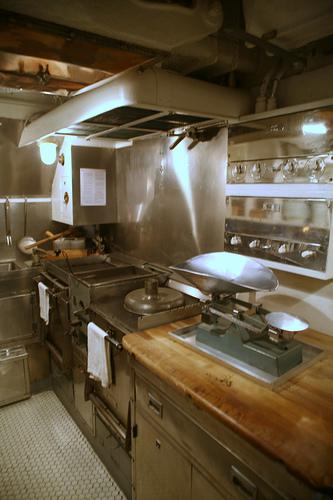Question: where is this shot taken?
Choices:
A. Living room.
B. Back yard.
C. Bedroom.
D. Kitchen.
Answer with the letter. Answer: D Question: what are the boxes with dials above counter?
Choices:
A. Broilers.
B. Microwave.
C. Toaster oven.
D. Range.
Answer with the letter. Answer: A Question: what is the countertop made of?
Choices:
A. Formica.
B. Wood.
C. Marble.
D. Laminate.
Answer with the letter. Answer: B Question: what is the machine on the counter top?
Choices:
A. Blender.
B. Microwave.
C. Toaster.
D. Scale.
Answer with the letter. Answer: D 